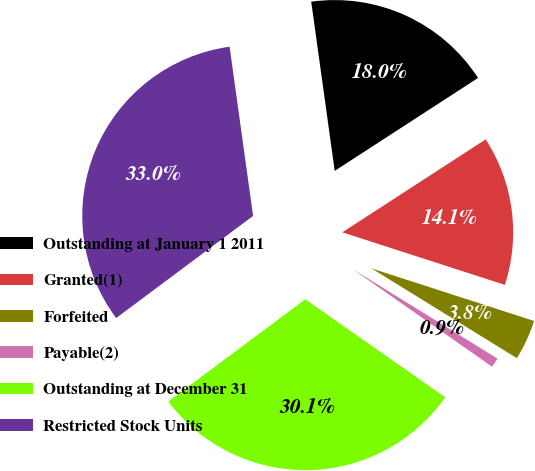Convert chart to OTSL. <chart><loc_0><loc_0><loc_500><loc_500><pie_chart><fcel>Outstanding at January 1 2011<fcel>Granted(1)<fcel>Forfeited<fcel>Payable(2)<fcel>Outstanding at December 31<fcel>Restricted Stock Units<nl><fcel>18.04%<fcel>14.13%<fcel>3.83%<fcel>0.91%<fcel>30.08%<fcel>33.0%<nl></chart> 